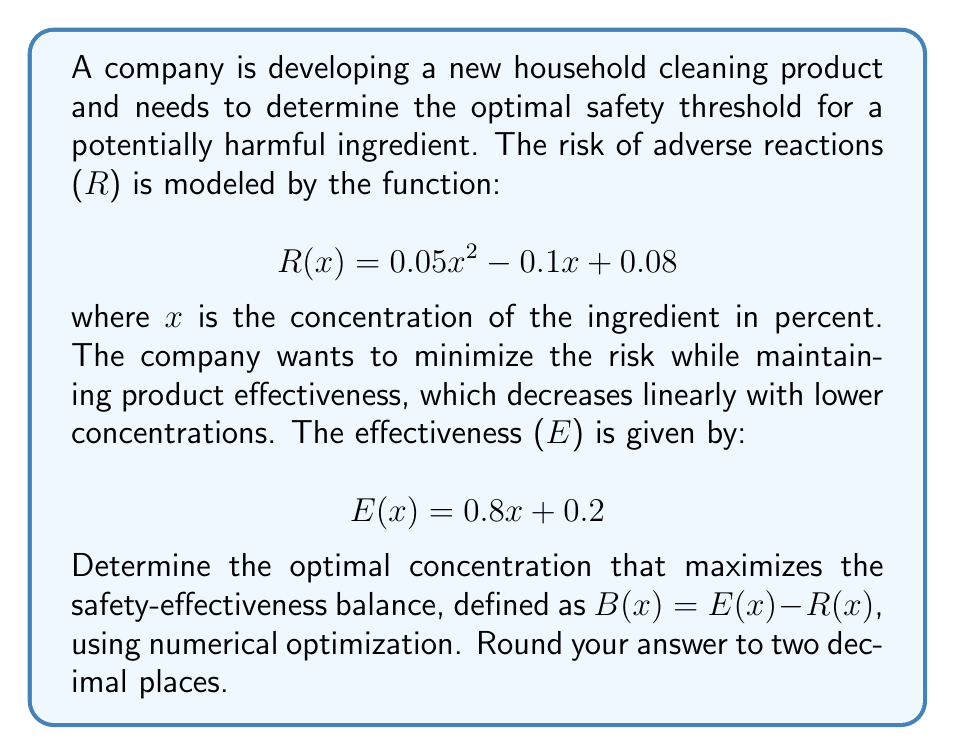Can you solve this math problem? To find the optimal concentration, we need to maximize the balance function B(x):

$$B(x) = E(x) - R(x) = (0.8x + 0.2) - (0.05x^2 - 0.1x + 0.08)$$

Simplifying:

$$B(x) = -0.05x^2 + 0.9x + 0.12$$

To find the maximum of this quadratic function, we can use calculus or numerical optimization. Let's use the derivative method:

1. Find the derivative of B(x):
   $$B'(x) = -0.1x + 0.9$$

2. Set the derivative to zero and solve for x:
   $$-0.1x + 0.9 = 0$$
   $$-0.1x = -0.9$$
   $$x = 9$$

3. Verify this is a maximum by checking the second derivative:
   $$B''(x) = -0.1$$
   Since B''(x) is negative, this confirms a maximum.

4. Calculate B(9) to confirm it's the highest point:
   $$B(9) = -0.05(9)^2 + 0.9(9) + 0.12 = -4.05 + 8.1 + 0.12 = 4.17$$

Therefore, the optimal concentration that maximizes the safety-effectiveness balance is 9%.

To verify numerically, we can check values around 9:

B(8.9) ≈ 4.1699
B(9.0) ≈ 4.1700
B(9.1) ≈ 4.1699

This confirms that 9% is indeed the optimal concentration.
Answer: The optimal concentration is 9.00%. 